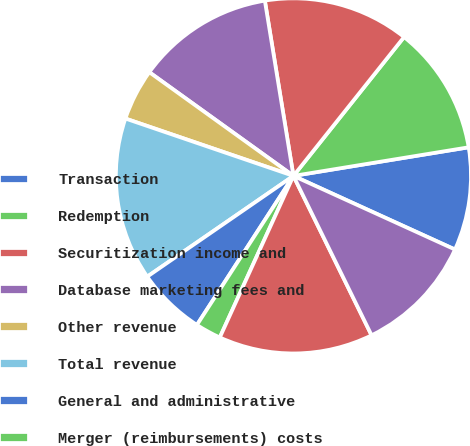Convert chart. <chart><loc_0><loc_0><loc_500><loc_500><pie_chart><fcel>Transaction<fcel>Redemption<fcel>Securitization income and<fcel>Database marketing fees and<fcel>Other revenue<fcel>Total revenue<fcel>General and administrative<fcel>Merger (reimbursements) costs<fcel>Total operating expenses<fcel>Operating income<nl><fcel>9.38%<fcel>11.72%<fcel>13.28%<fcel>12.5%<fcel>4.69%<fcel>14.84%<fcel>6.25%<fcel>2.34%<fcel>14.06%<fcel>10.94%<nl></chart> 